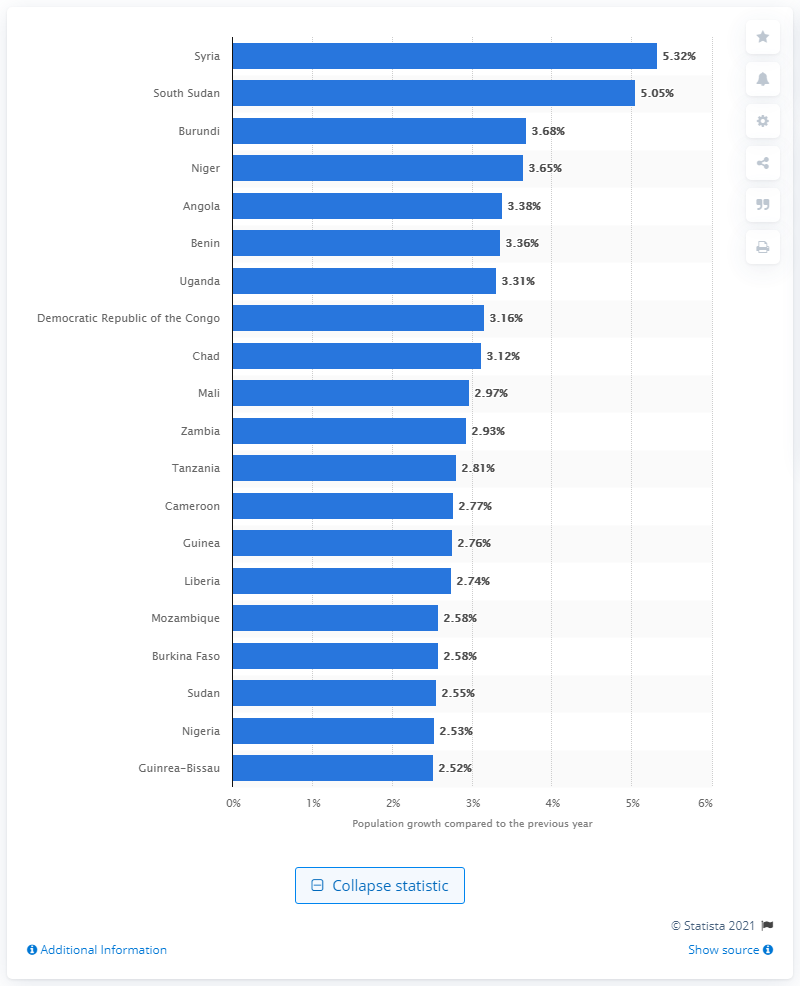Indicate a few pertinent items in this graphic. In 2021, the population growth rate in Syria was 5.32%. 